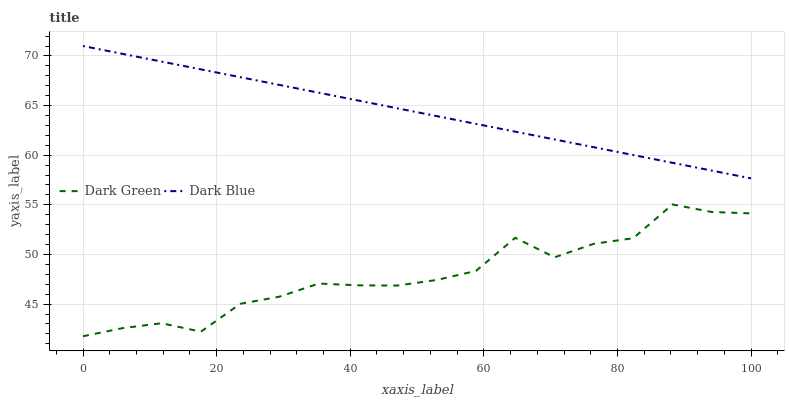Does Dark Green have the minimum area under the curve?
Answer yes or no. Yes. Does Dark Blue have the maximum area under the curve?
Answer yes or no. Yes. Does Dark Green have the maximum area under the curve?
Answer yes or no. No. Is Dark Blue the smoothest?
Answer yes or no. Yes. Is Dark Green the roughest?
Answer yes or no. Yes. Is Dark Green the smoothest?
Answer yes or no. No. Does Dark Green have the lowest value?
Answer yes or no. Yes. Does Dark Blue have the highest value?
Answer yes or no. Yes. Does Dark Green have the highest value?
Answer yes or no. No. Is Dark Green less than Dark Blue?
Answer yes or no. Yes. Is Dark Blue greater than Dark Green?
Answer yes or no. Yes. Does Dark Green intersect Dark Blue?
Answer yes or no. No. 